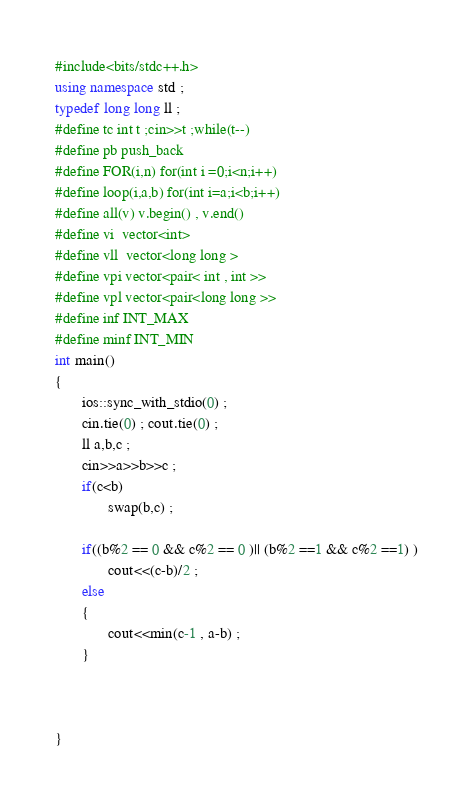<code> <loc_0><loc_0><loc_500><loc_500><_C++_>#include<bits/stdc++.h>
using namespace std ;
typedef long long ll ;
#define tc int t ;cin>>t ;while(t--)
#define pb push_back
#define FOR(i,n) for(int i =0;i<n;i++)
#define loop(i,a,b) for(int i=a;i<b;i++)
#define all(v) v.begin() , v.end()
#define vi  vector<int>
#define vll  vector<long long >
#define vpi vector<pair< int , int >>
#define vpl vector<pair<long long >>
#define inf INT_MAX
#define minf INT_MIN
int main()
{
       ios::sync_with_stdio(0) ;
       cin.tie(0) ; cout.tie(0) ;
       ll a,b,c ;
       cin>>a>>b>>c ;
       if(c<b)
              swap(b,c) ;

       if((b%2 == 0 && c%2 == 0 )|| (b%2 ==1 && c%2 ==1) )
              cout<<(c-b)/2 ;
       else
       {
              cout<<min(c-1 , a-b) ;
       }



}
</code> 